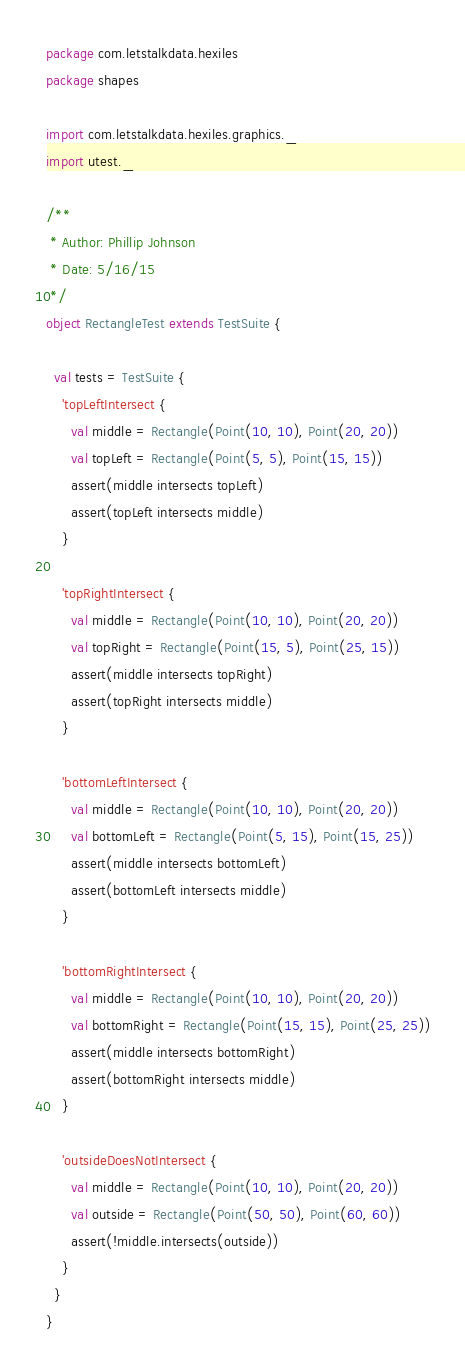<code> <loc_0><loc_0><loc_500><loc_500><_Scala_>package com.letstalkdata.hexiles
package shapes

import com.letstalkdata.hexiles.graphics._
import utest._

/**
 * Author: Phillip Johnson
 * Date: 5/16/15
 */
object RectangleTest extends TestSuite {

  val tests = TestSuite {
    'topLeftIntersect {
      val middle = Rectangle(Point(10, 10), Point(20, 20))
      val topLeft = Rectangle(Point(5, 5), Point(15, 15))
      assert(middle intersects topLeft)
      assert(topLeft intersects middle)
    }

    'topRightIntersect {
      val middle = Rectangle(Point(10, 10), Point(20, 20))
      val topRight = Rectangle(Point(15, 5), Point(25, 15))
      assert(middle intersects topRight)
      assert(topRight intersects middle)
    }

    'bottomLeftIntersect {
      val middle = Rectangle(Point(10, 10), Point(20, 20))
      val bottomLeft = Rectangle(Point(5, 15), Point(15, 25))
      assert(middle intersects bottomLeft)
      assert(bottomLeft intersects middle)
    }

    'bottomRightIntersect {
      val middle = Rectangle(Point(10, 10), Point(20, 20))
      val bottomRight = Rectangle(Point(15, 15), Point(25, 25))
      assert(middle intersects bottomRight)
      assert(bottomRight intersects middle)
    }

    'outsideDoesNotIntersect {
      val middle = Rectangle(Point(10, 10), Point(20, 20))
      val outside = Rectangle(Point(50, 50), Point(60, 60))
      assert(!middle.intersects(outside))
    }
  }
}
</code> 